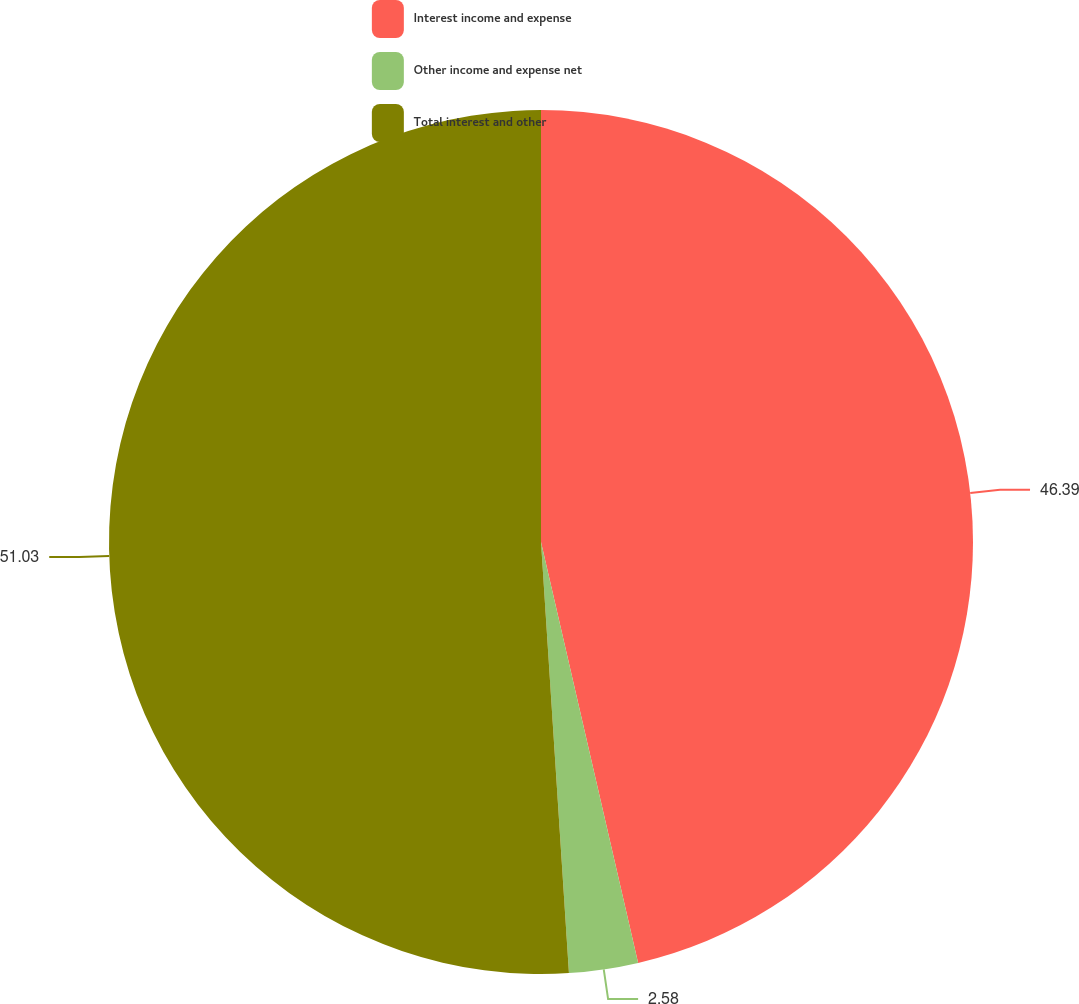<chart> <loc_0><loc_0><loc_500><loc_500><pie_chart><fcel>Interest income and expense<fcel>Other income and expense net<fcel>Total interest and other<nl><fcel>46.39%<fcel>2.58%<fcel>51.03%<nl></chart> 